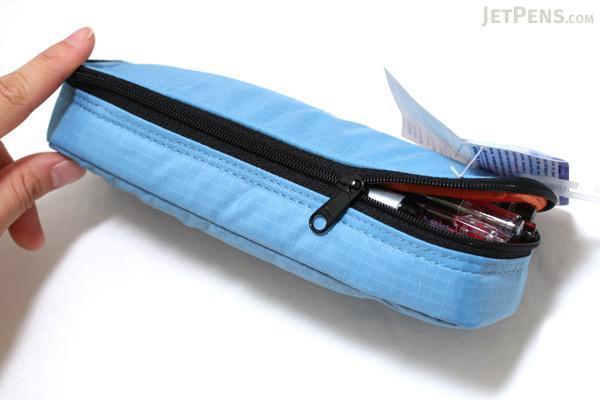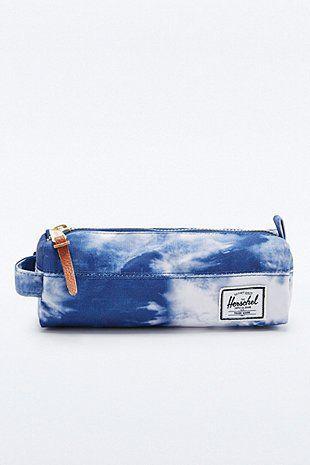The first image is the image on the left, the second image is the image on the right. For the images displayed, is the sentence "There is 1 pencil case that is fully open displaying pencils and pens." factually correct? Answer yes or no. No. The first image is the image on the left, the second image is the image on the right. Evaluate the accuracy of this statement regarding the images: "The image to the left features exactly one case, and it is open.". Is it true? Answer yes or no. Yes. 